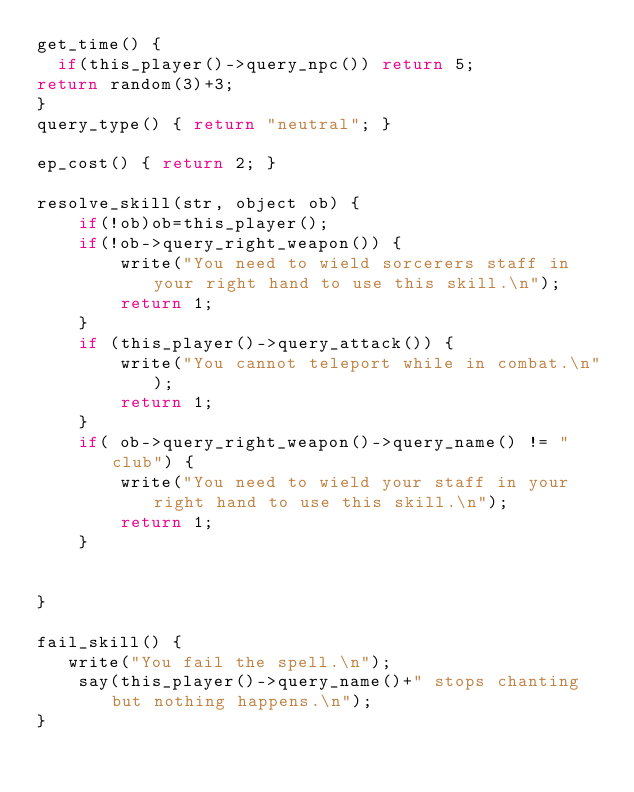Convert code to text. <code><loc_0><loc_0><loc_500><loc_500><_C_>get_time() {
  if(this_player()->query_npc()) return 5;
return random(3)+3;
}
query_type() { return "neutral"; }

ep_cost() { return 2; }

resolve_skill(str, object ob) {
    if(!ob)ob=this_player();
    if(!ob->query_right_weapon()) {
        write("You need to wield sorcerers staff in your right hand to use this skill.\n");
        return 1;
    }
    if (this_player()->query_attack()) {
        write("You cannot teleport while in combat.\n");
        return 1;
    }
    if( ob->query_right_weapon()->query_name() != "club") {
        write("You need to wield your staff in your right hand to use this skill.\n");
        return 1;
    }


}

fail_skill() {
   write("You fail the spell.\n");
    say(this_player()->query_name()+" stops chanting but nothing happens.\n");
}

</code> 